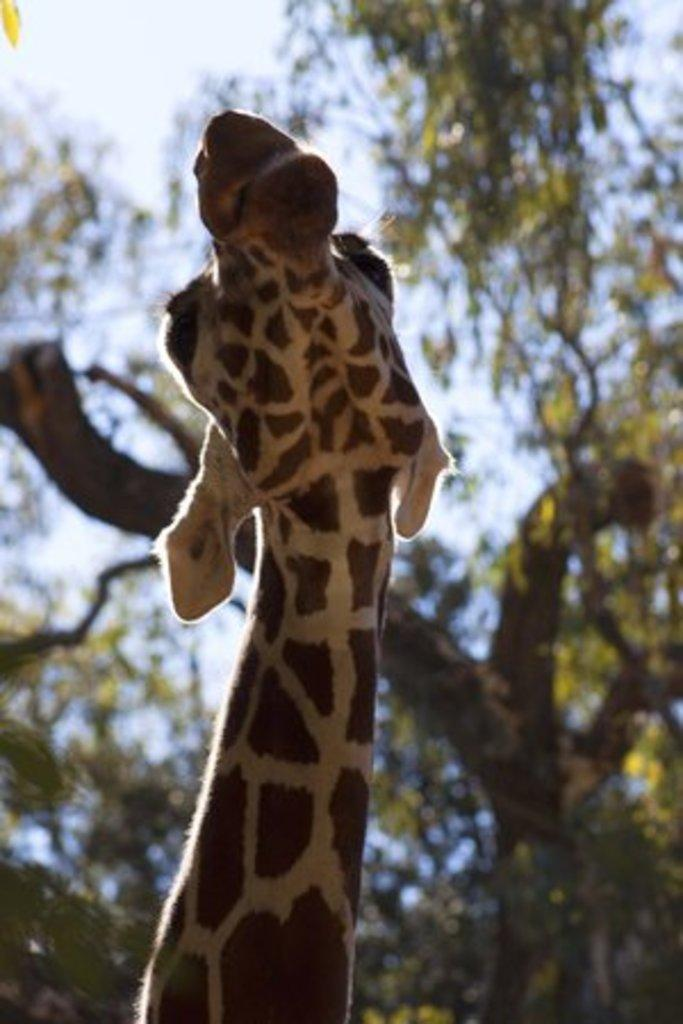What animal is in the foreground of the image? There is a giraffe in the foreground of the image. What can be seen in the background of the image? There are trees in the background of the image. What is visible at the top of the image? The sky is visible at the top of the image. What type of jewel is hanging from the giraffe's neck in the image? There is no jewel hanging from the giraffe's neck in the image; the giraffe is not adorned with any jewelry. 